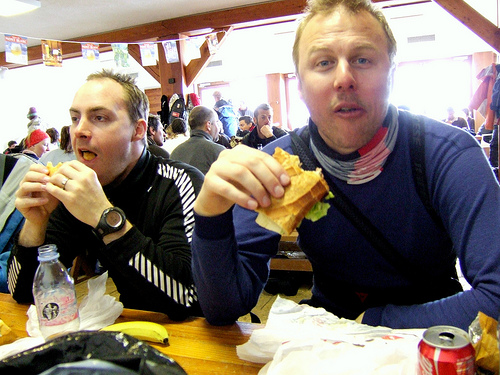<image>
Is the sandwich in front of the man? No. The sandwich is not in front of the man. The spatial positioning shows a different relationship between these objects. 